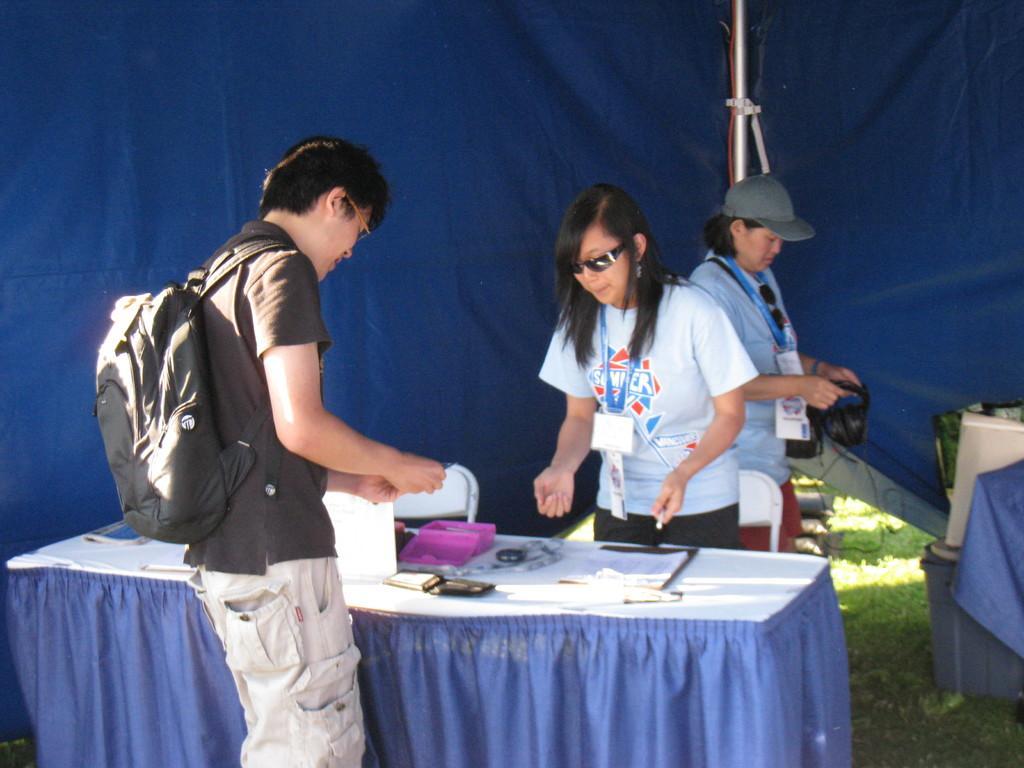In one or two sentences, can you explain what this image depicts? In this picture i could see three persons one of the person is wearing a back pack. He is wearing a black shirt and a grey colored short standing near by the table and watching some thing on the table. Beside the table there is other girl standing she is having a google's, she is wearing a white t shirt and a black short. At the back of her the other lady having a cap holding some stuff in her hand in the back ground i could see a blue colored tent and on the floor there is a grass. 